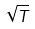<formula> <loc_0><loc_0><loc_500><loc_500>\sqrt { T }</formula> 